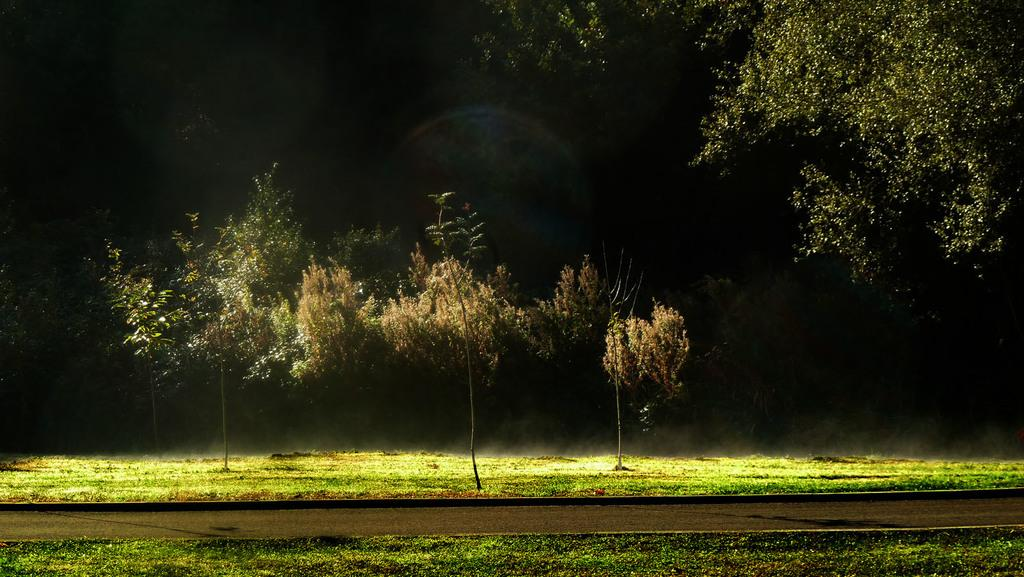What type of vegetation can be seen in the image? There are trees in the image. What is covering the ground in the image? There is grass on the ground in the image. What tool is being used to care for the trees in the image? There is no tool or care activity depicted in the image; it only shows trees and grass. What is the sun doing in the image? The sun is not present in the image; it is a photograph of trees and grass. 